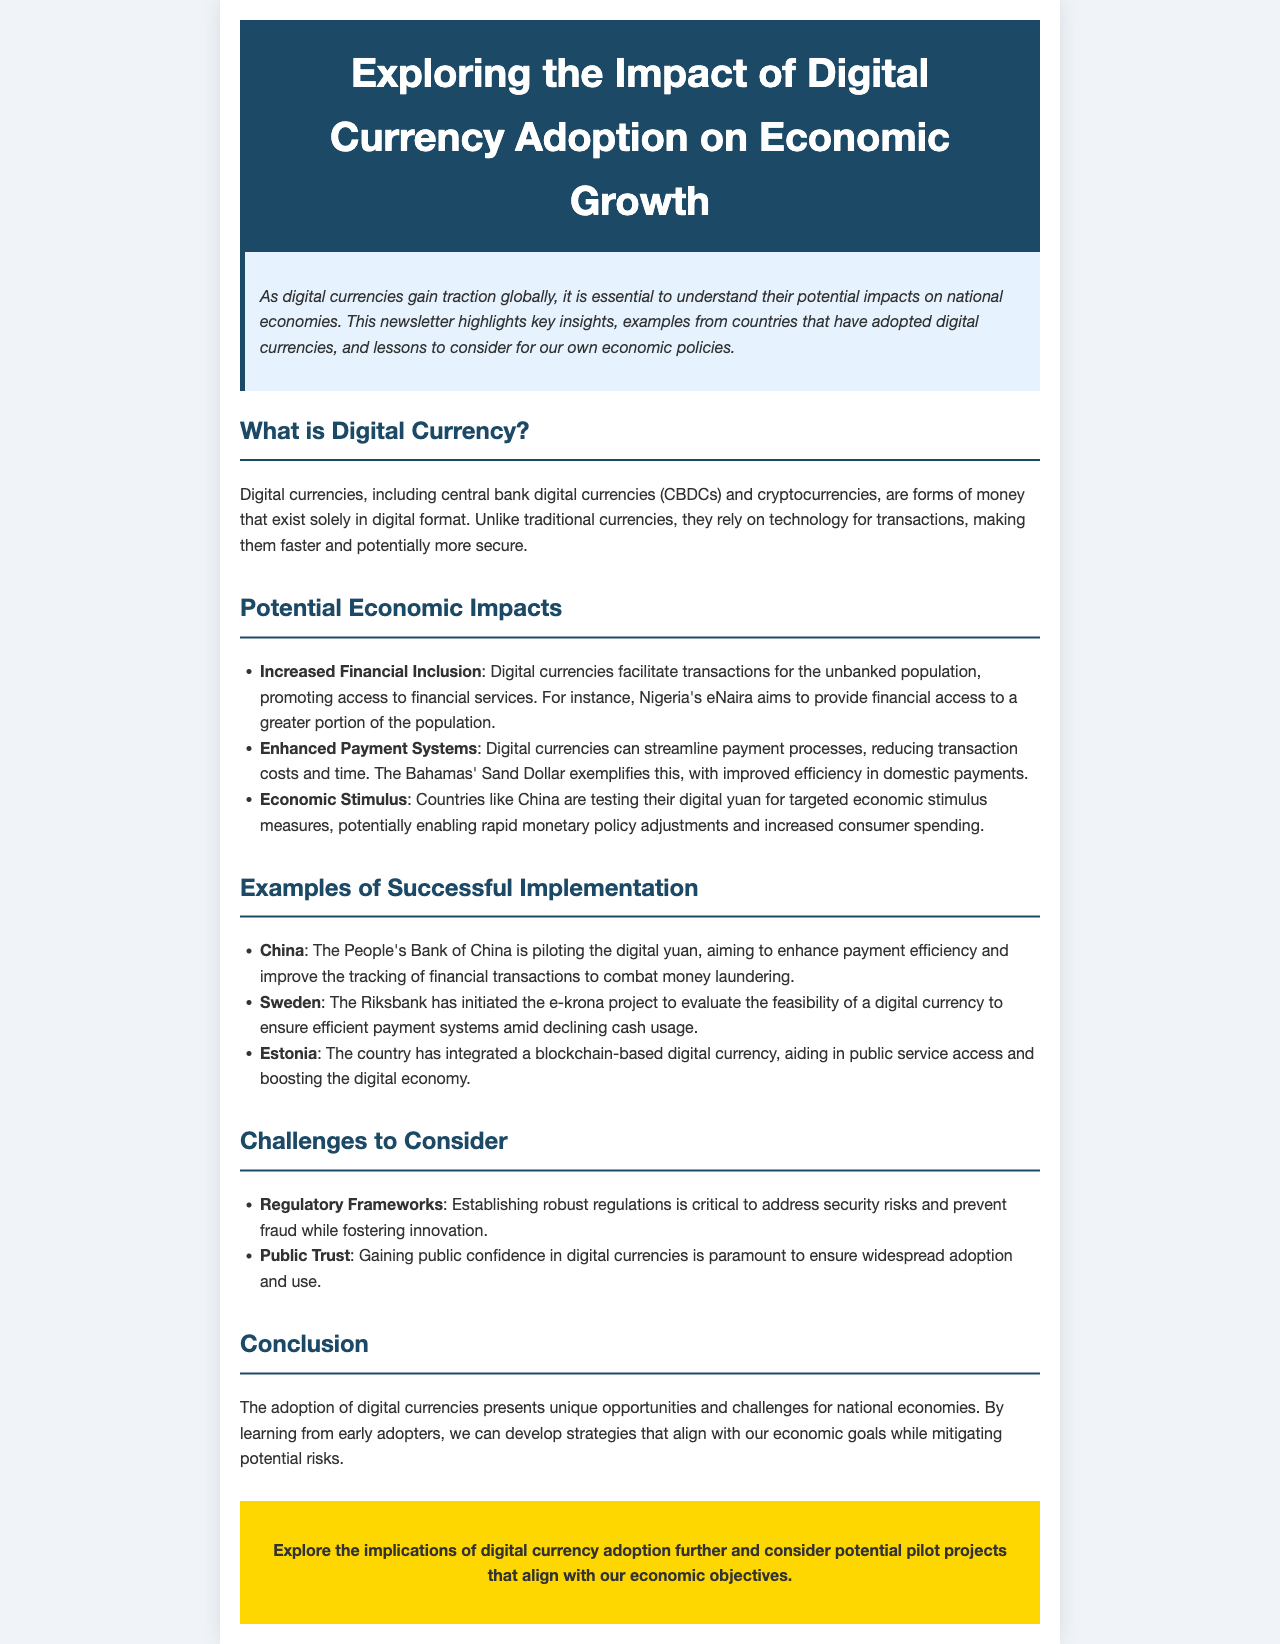What is digital currency? Digital currency is defined in the document as forms of money that exist solely in digital format, including central bank digital currencies and cryptocurrencies.
Answer: Forms of money existing solely in digital format What is the name of Nigeria's digital currency? The document mentions Nigeria's digital currency as eNaira, which aims to provide financial access to a greater portion of the population.
Answer: eNaira Which country is testing its digital currency for economic stimulus? According to the document, China is testing its digital yuan for targeted economic stimulus measures.
Answer: China What is one challenge of digital currency adoption mentioned in the document? The document lists regulatory frameworks as a challenge crucial for addressing security risks and preventing fraud.
Answer: Regulatory frameworks What project is Sweden implementing to evaluate digital currency feasibility? The document refers to Sweden's e-krona project as an initiative to assess the feasibility of a digital currency for efficient payment systems.
Answer: e-krona project Which country integrated a blockchain-based digital currency? The document states that Estonia has integrated a blockchain-based digital currency to aid in public service access and boost the digital economy.
Answer: Estonia What does the Bahamas' Sand Dollar improve? The document highlights that the Bahamas' Sand Dollar exemplifies improved efficiency in domestic payments for digital currency.
Answer: Domestic payments What is a key requirement for gaining public adoption of digital currencies? The document indicates that gaining public trust is paramount to ensure widespread adoption and use of digital currencies.
Answer: Public trust 